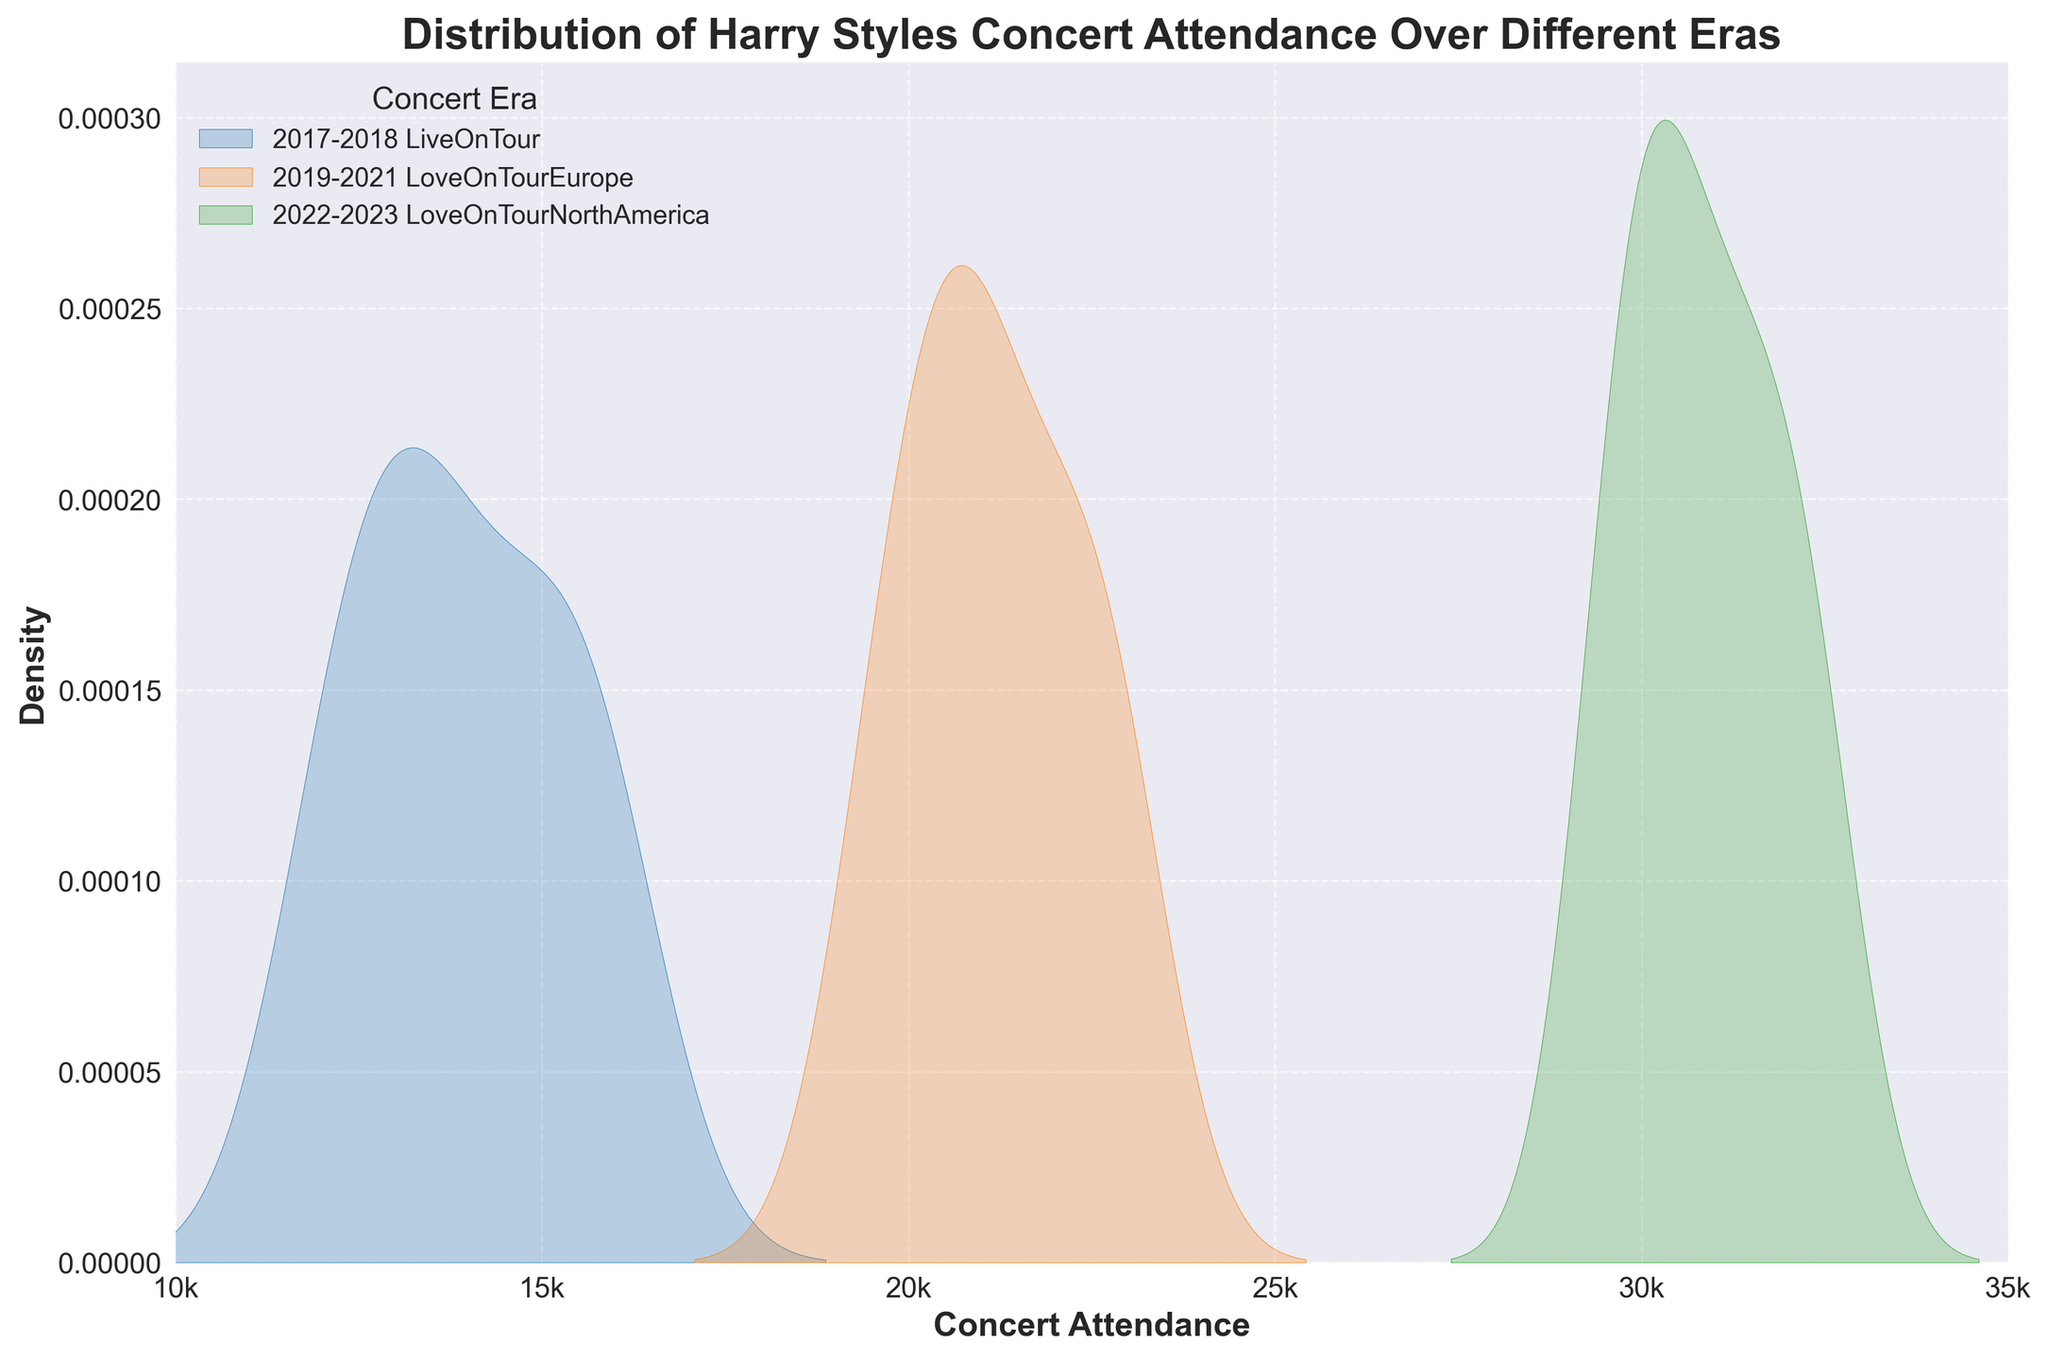what is the title of the plot? The title can be found at the top of the plot. The text reads "Distribution of Harry Styles Concert Attendance Over Different Eras"
Answer: Distribution of Harry Styles Concert Attendance Over Different Eras Which era has the highest peak density? Looking at the density plot, the highest peak density is the one with the tallest curve. The era with the tallest curve is "2022-2023 Love On Tour North America."
Answer: 2022-2023 Love On Tour North America What is the range of attendance for "2017-2018 Live On Tour"? The range of the attendance data for "2017-2018 Live On Tour" can be seen by identifying the minimum and maximum points along the x-axis for its density curve. The range is from about 12,000 to 16,000.
Answer: 12,000 to 16,000 Which era shows an attendance range that exceeds 30,000? The density plot for "2022-2023 Love On Tour North America" extends beyond 30,000 on the x-axis.
Answer: 2022-2023 Love On Tour North America How does the average attendance of "2019-2021 Love On Tour Europe" compare to "2017-2018 Live On Tour"? The peak of "2019-2021 Love On Tour Europe" density curve is around a higher attendance on the x-axis compared to "2017-2018 Live On Tour". Thus, the average attendance for "2019-2021 Love On Tour Europe" appears higher.
Answer: Higher What is the x-axis label? The x-axis label is the text below the horizontal axis of the plot. The label reads "Concert Attendance."
Answer: Concert Attendance Which era had the most consistent attendance? Consistency can be inferred from the width of the density plot. "2019-2021 Love On Tour Europe" has a sharper, less spread-out peak, indicating more consistent attendance values around the mean.
Answer: 2019-2021 Love On Tour Europe What are the tick marks on the x-axis? The tick marks on the x-axis are the points marked along the axis to indicate the scale. The ticks here are at 10,000, 15,000, 20,000, 25,000, 30,000, and 35,000, labeled as 10k, 15k, 20k, 25k, 30k, 35k.
Answer: 10k, 15k, 20k, 25k, 30k, 35k How does the density for "2017-2018 Live On Tour" compare to the density for "2022-2023 Love On Tour North America" at an attendance of 15,000? At an attendance of 15,000, the density for "2017-2018 Live On Tour" is higher than that for "2022-2023 Love On Tour North America" because the peak of the former's curve is more pronounced here.
Answer: 2017-2018 Live On Tour 